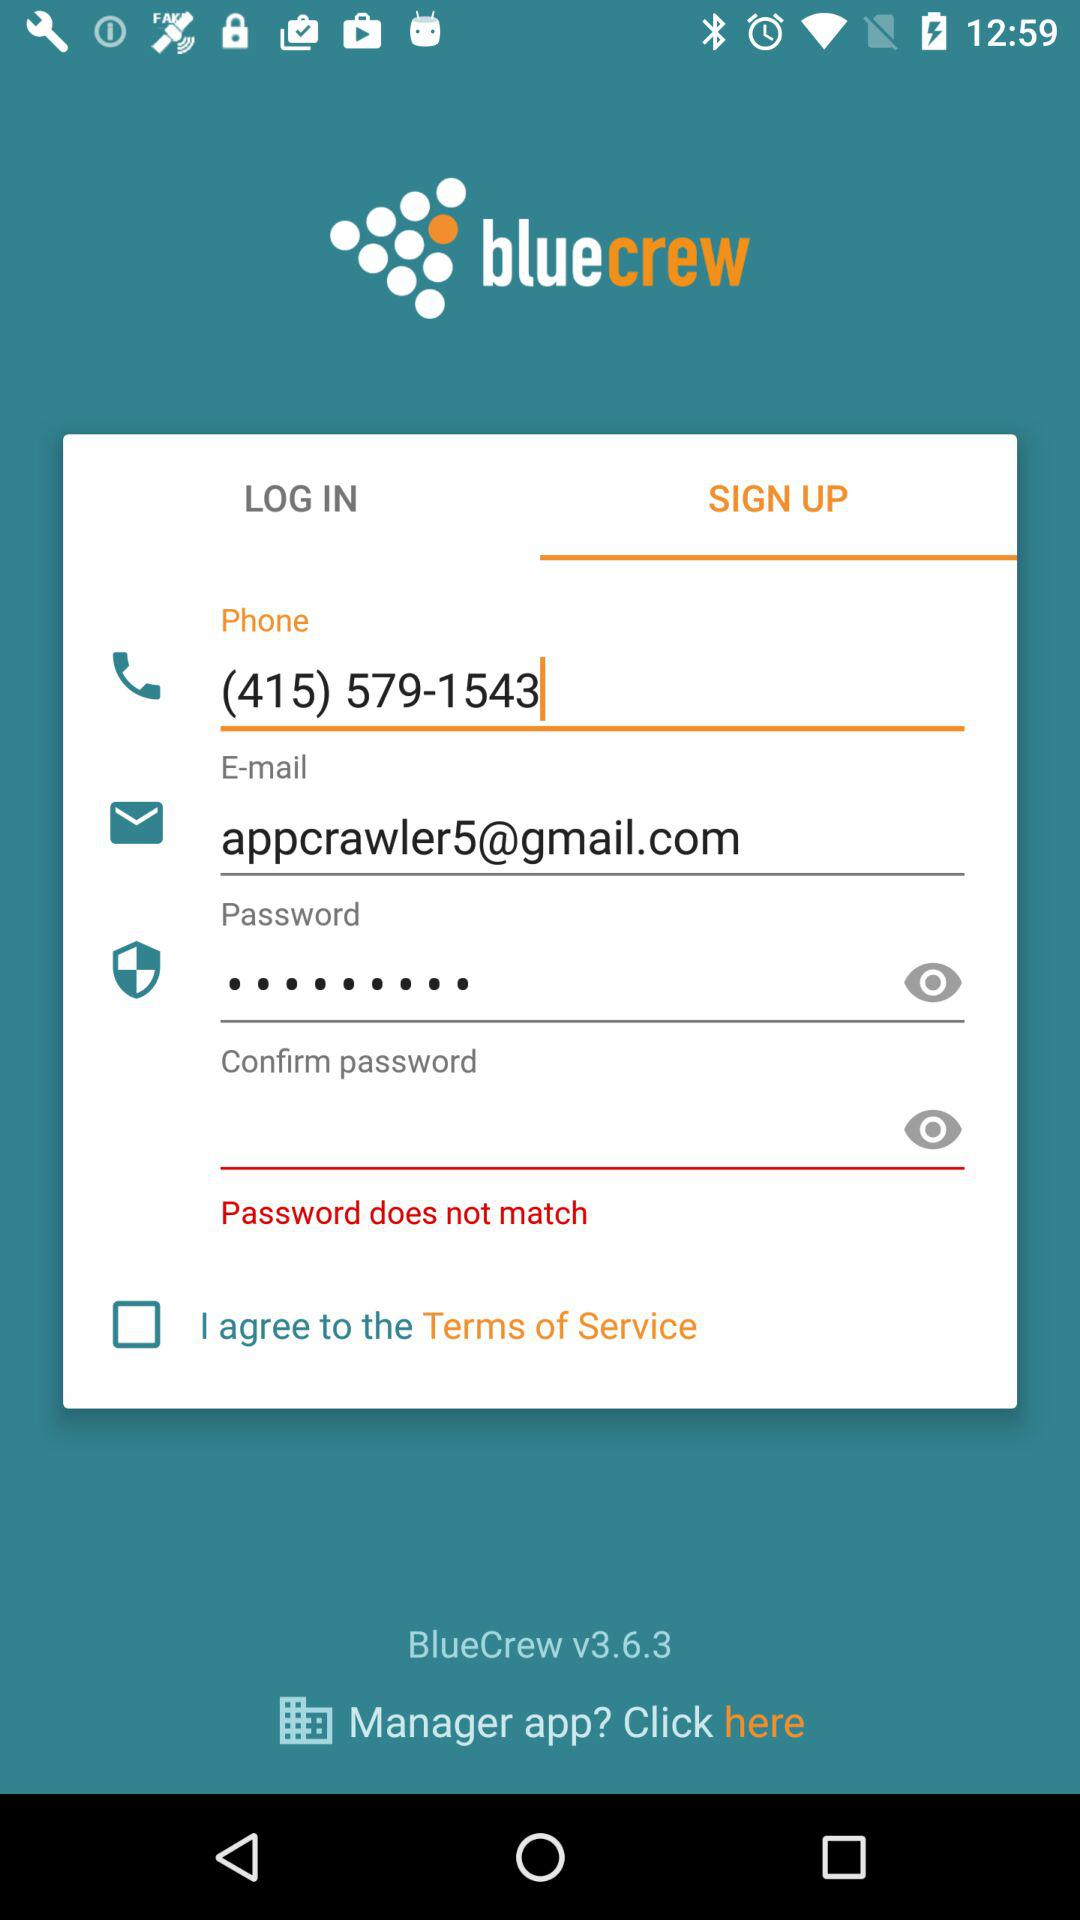Which tab has been selected? The selected tab is "SIGN UP". 